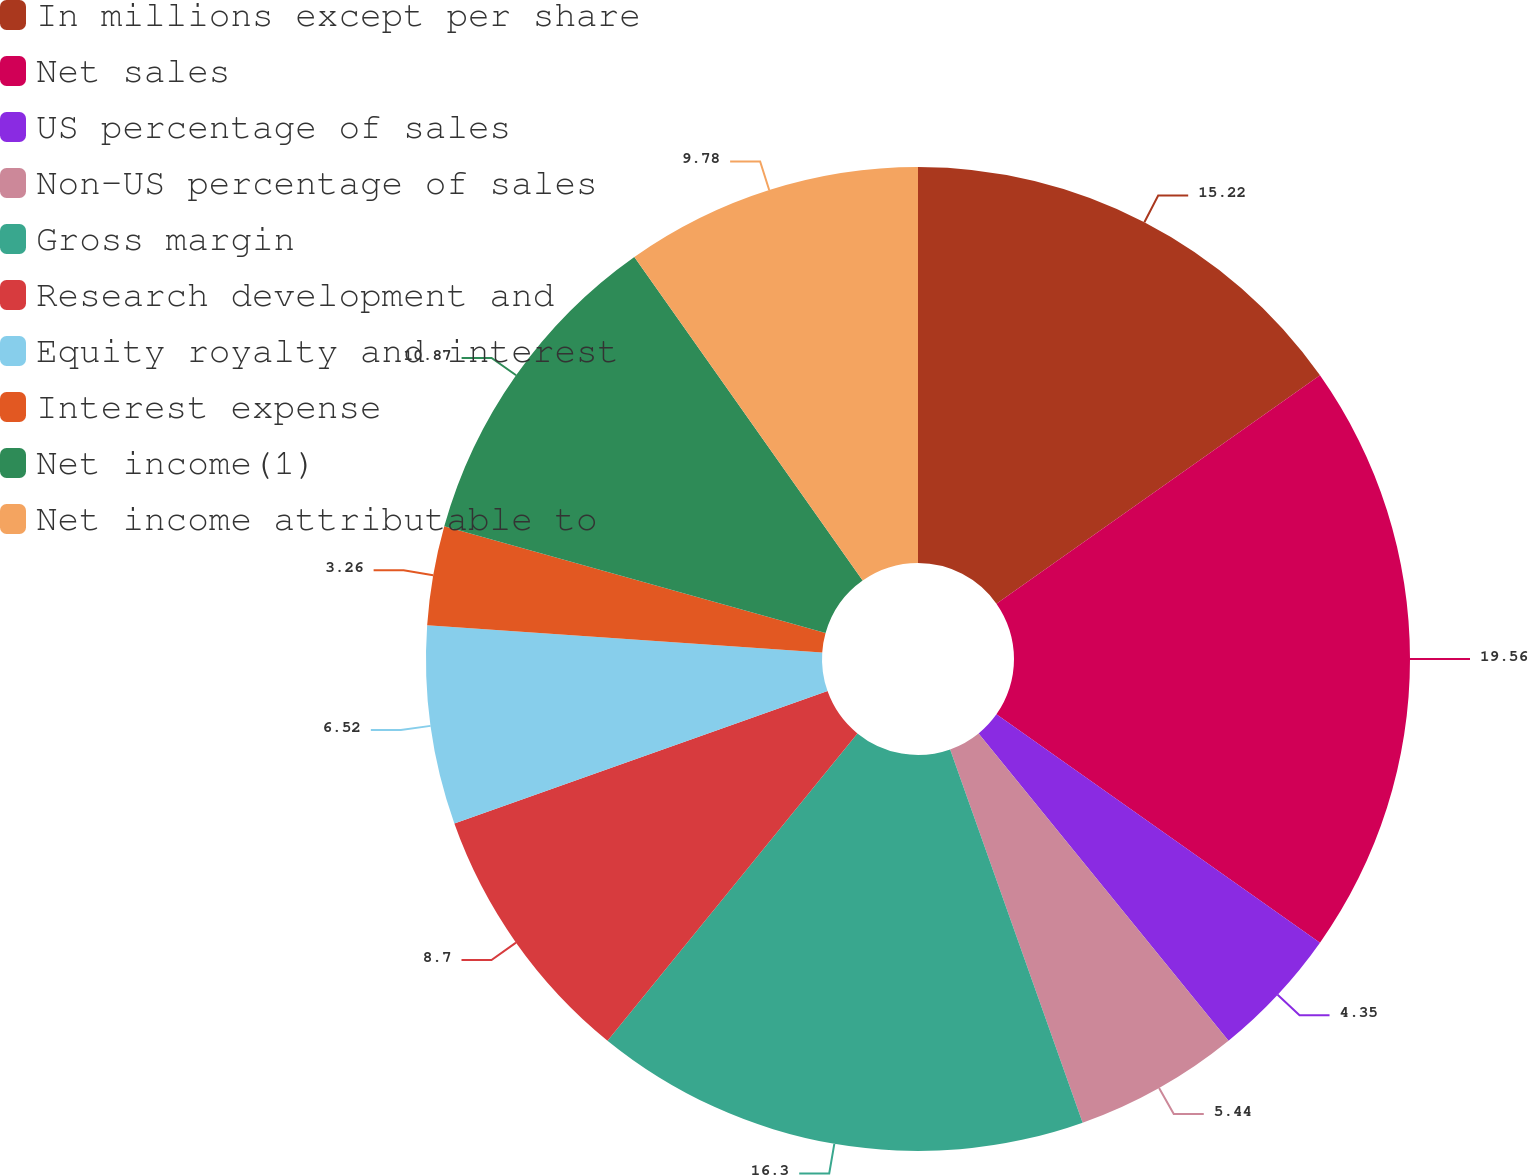Convert chart to OTSL. <chart><loc_0><loc_0><loc_500><loc_500><pie_chart><fcel>In millions except per share<fcel>Net sales<fcel>US percentage of sales<fcel>Non-US percentage of sales<fcel>Gross margin<fcel>Research development and<fcel>Equity royalty and interest<fcel>Interest expense<fcel>Net income(1)<fcel>Net income attributable to<nl><fcel>15.22%<fcel>19.56%<fcel>4.35%<fcel>5.44%<fcel>16.3%<fcel>8.7%<fcel>6.52%<fcel>3.26%<fcel>10.87%<fcel>9.78%<nl></chart> 